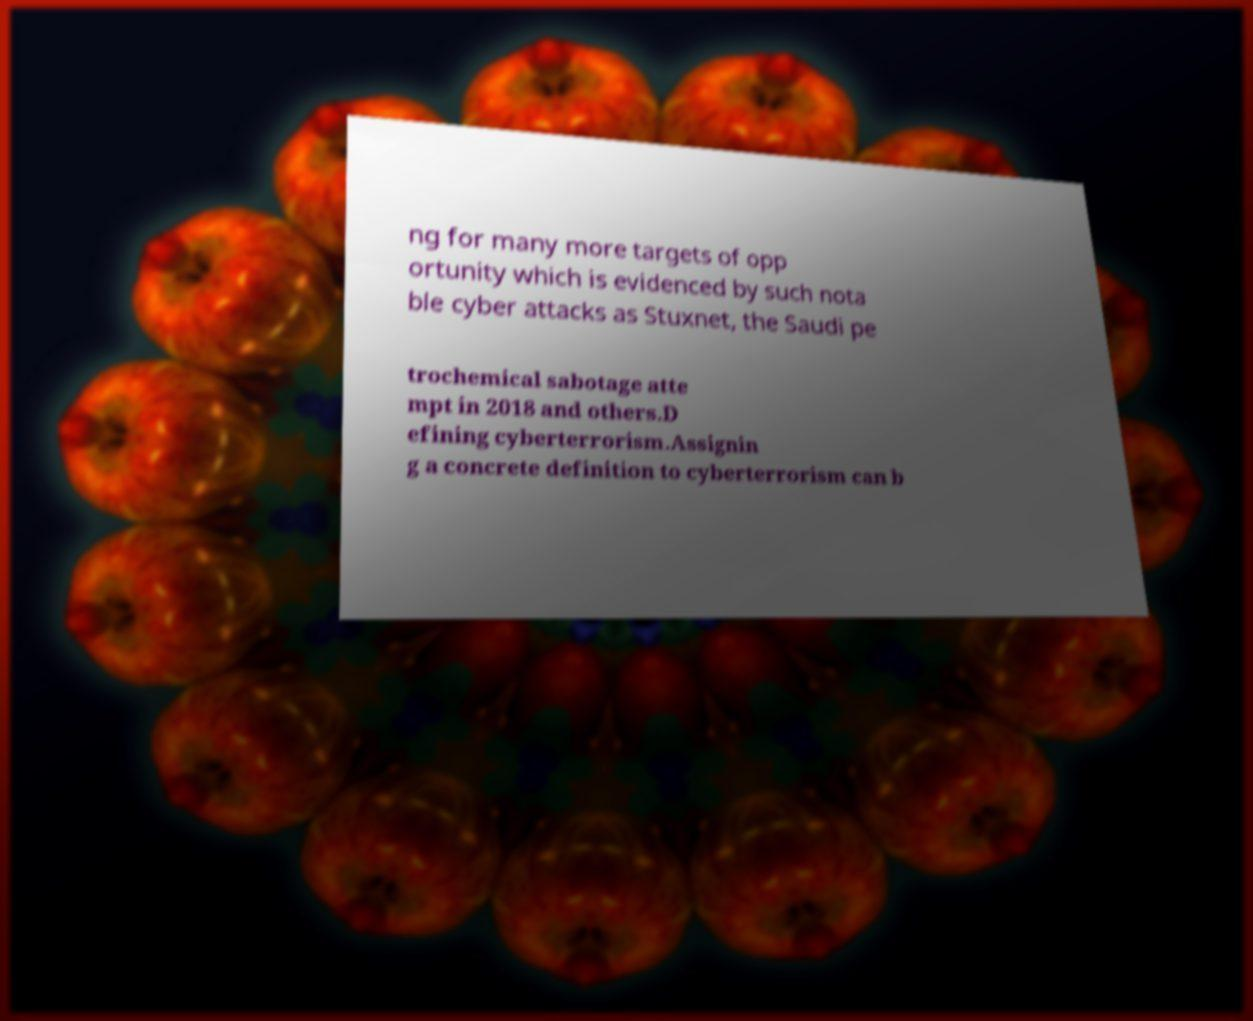Could you assist in decoding the text presented in this image and type it out clearly? ng for many more targets of opp ortunity which is evidenced by such nota ble cyber attacks as Stuxnet, the Saudi pe trochemical sabotage atte mpt in 2018 and others.D efining cyberterrorism.Assignin g a concrete definition to cyberterrorism can b 